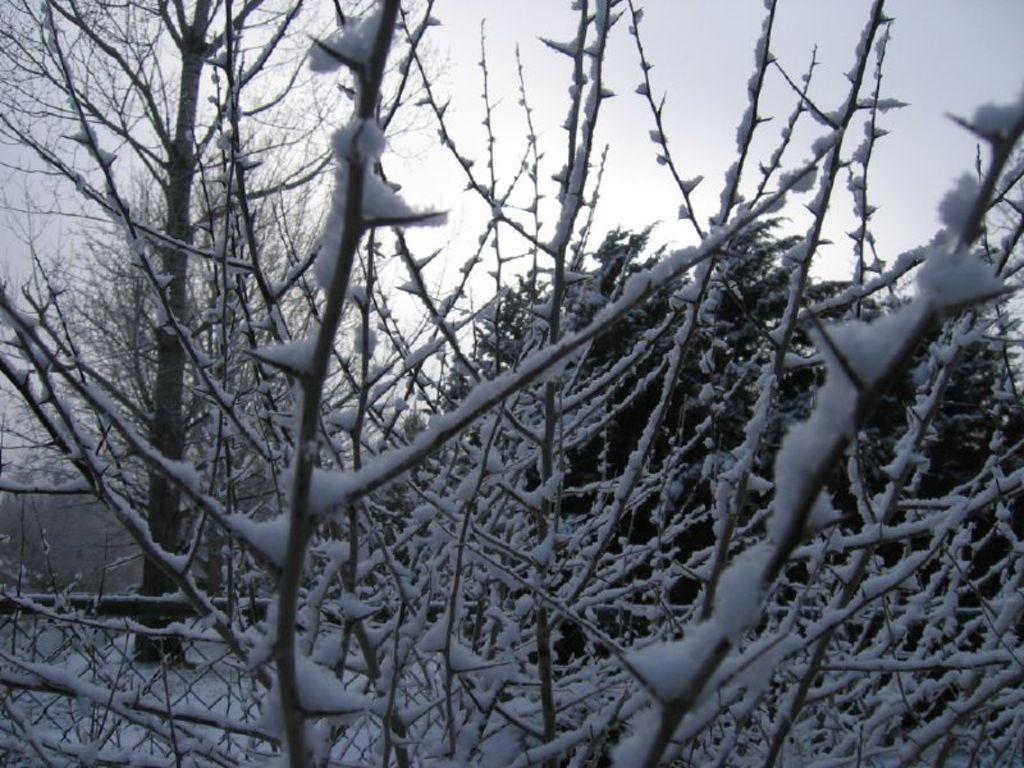Can you describe this image briefly? In this picture there are trees and there is snow on the trees. At the top there is sky. At the bottom there is snow. 